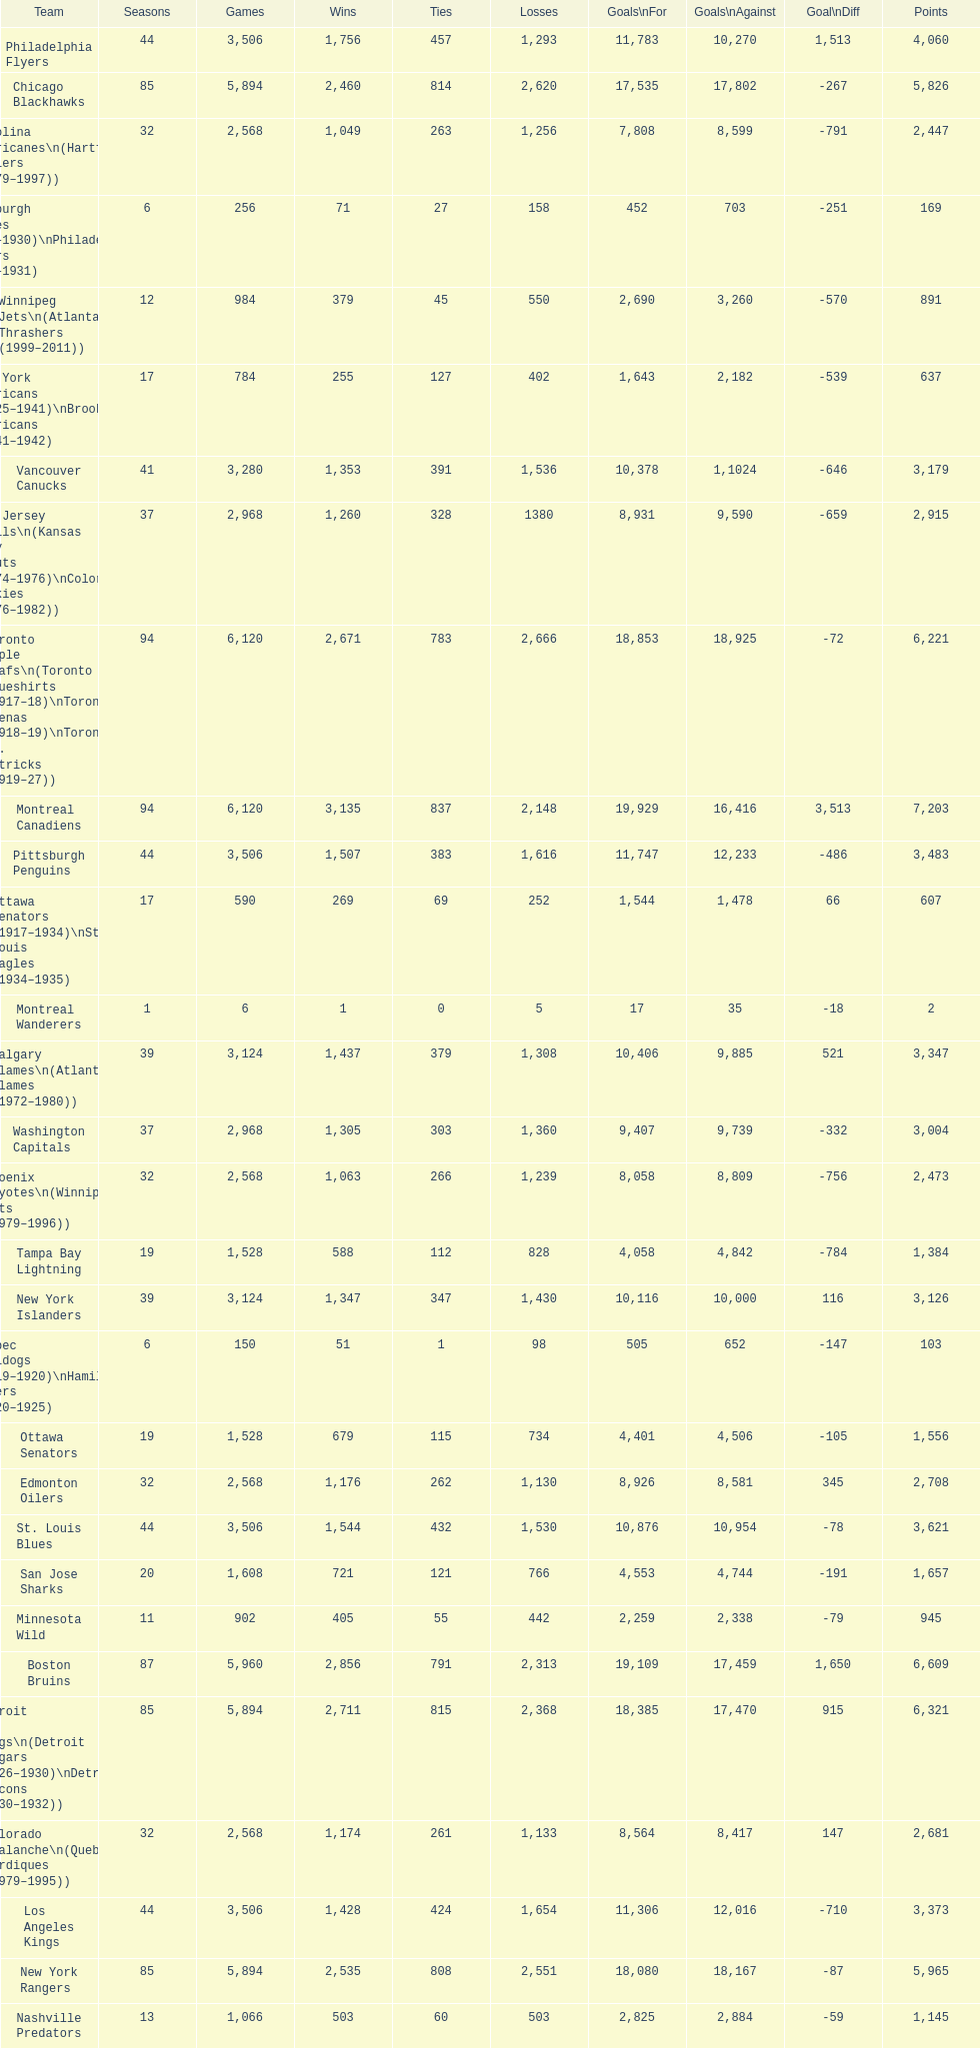Who has the least amount of losses? Montreal Wanderers. 